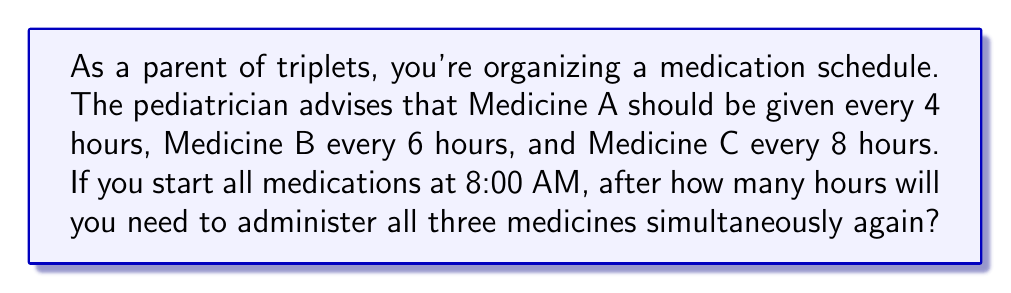Can you answer this question? To solve this problem, we need to find the least common multiple (LCM) of 4, 6, and 8 hours.

Step 1: Prime factorize each number
$4 = 2^2$
$6 = 2 \times 3$
$8 = 2^3$

Step 2: Take each prime factor to the highest power in which it occurs in any of the numbers
$2$ appears with a maximum power of 3 (in 8)
$3$ appears with a power of 1 (in 6)

Step 3: Multiply these highest powers
$LCM = 2^3 \times 3 = 8 \times 3 = 24$

Therefore, all three medicines will need to be administered simultaneously again after 24 hours.

Verification:
$24 \div 4 = 6$ (whole number)
$24 \div 6 = 4$ (whole number)
$24 \div 8 = 3$ (whole number)

This confirms that 24 is divisible by all three intervals.
Answer: 24 hours 